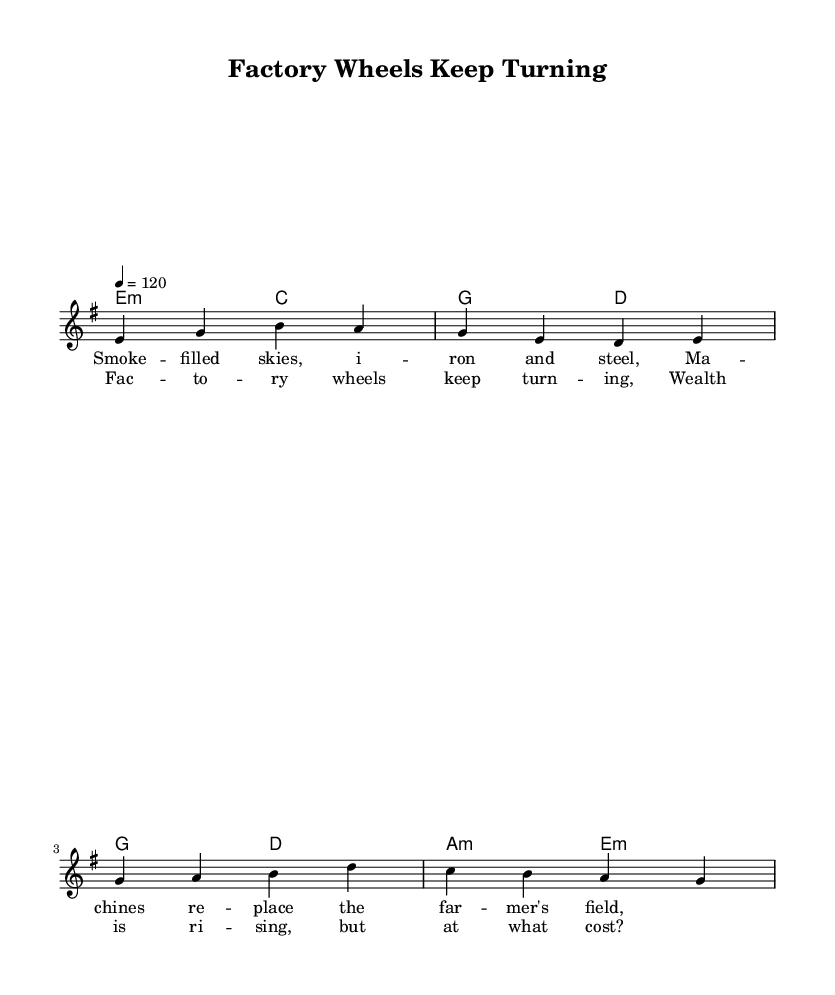What is the key signature of this music? The key signature can be found at the beginning of the score. Here, it indicates E minor, which has one sharp (F#).
Answer: E minor What is the time signature of this music? The time signature is located at the beginning of the score, indicating it is in 4/4 time. This means there are four beats in each measure, and a quarter note gets one beat.
Answer: 4/4 What is the tempo of this music? The tempo is specified in the score. It indicates that the music should be played at a speed of quarter note = 120 beats per minute.
Answer: 120 How many measures are in the verse section? To find the number of measures in the verse, look at the melody section. The verse contains four measures, as shown by the four groups of notes.
Answer: 4 What type of chord follows the first melody note in the verse? The first melody note of the verse is E, and the corresponding chord in the harmony part is E minor. This harmony starts with an E minor chord.
Answer: E minor What is the primary theme of the lyrics? Analyzing the lyrics provided, they focus on the industrial transformation caused by machinery and the impact it has on traditional agricultural lifestyles, pointing to economic consequences.
Answer: Industrial transformation Which section of the song does the phrase "Factory wheels keep turning" belong to? Looking at the lyrics, this specific phrase is part of the chorus section, which typically follows the verse in a song structure.
Answer: Chorus 